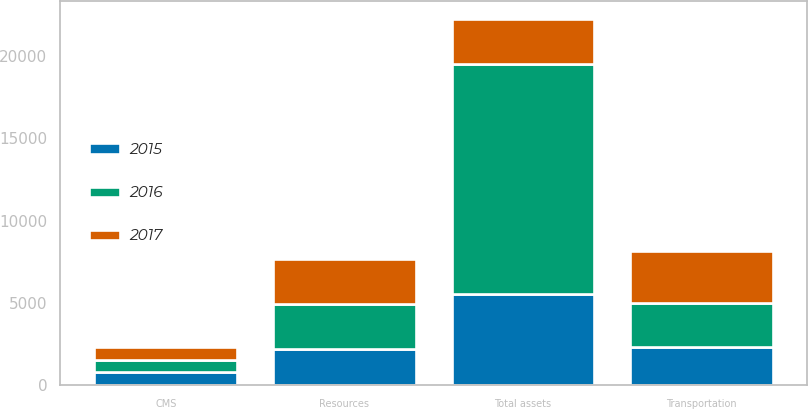<chart> <loc_0><loc_0><loc_500><loc_500><stacked_bar_chart><ecel><fcel>Resources<fcel>Transportation<fcel>CMS<fcel>Total assets<nl><fcel>2017<fcel>2720.7<fcel>3152<fcel>772.4<fcel>2719.7<nl><fcel>2016<fcel>2719.7<fcel>2721.3<fcel>726.4<fcel>13936.6<nl><fcel>2015<fcel>2238.1<fcel>2310.9<fcel>835.1<fcel>5577.5<nl></chart> 